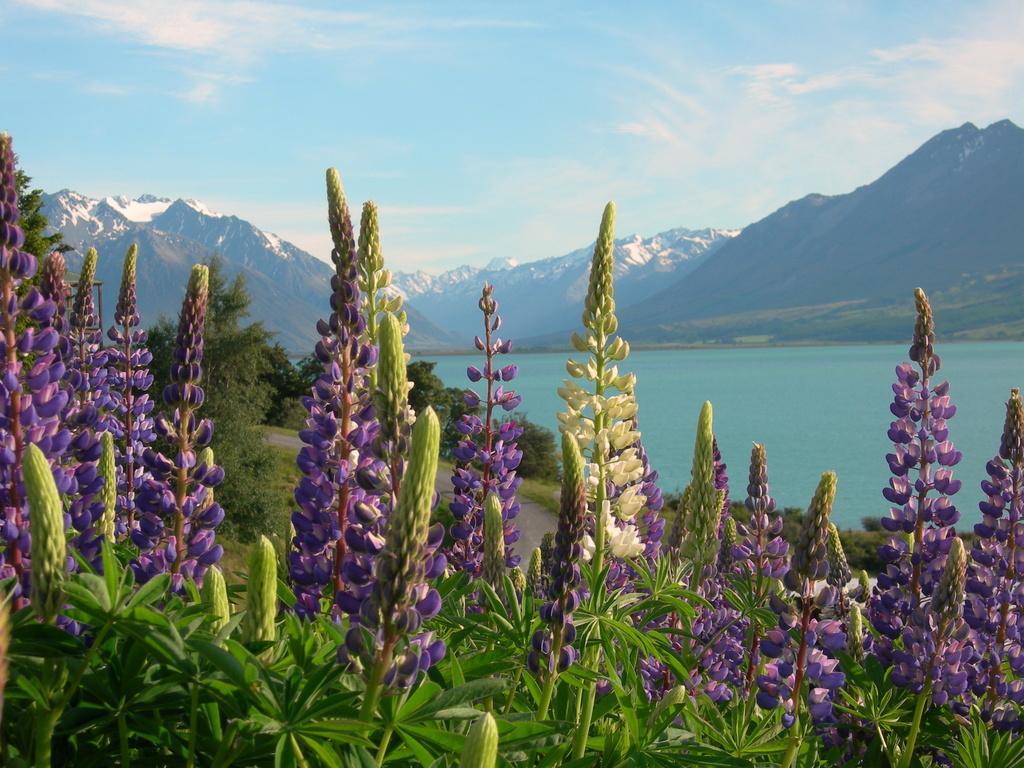In one or two sentences, can you explain what this image depicts? In this picture there are few flowers which are in violet and white color and there are trees in front of them and there are mountains and water in the background. 